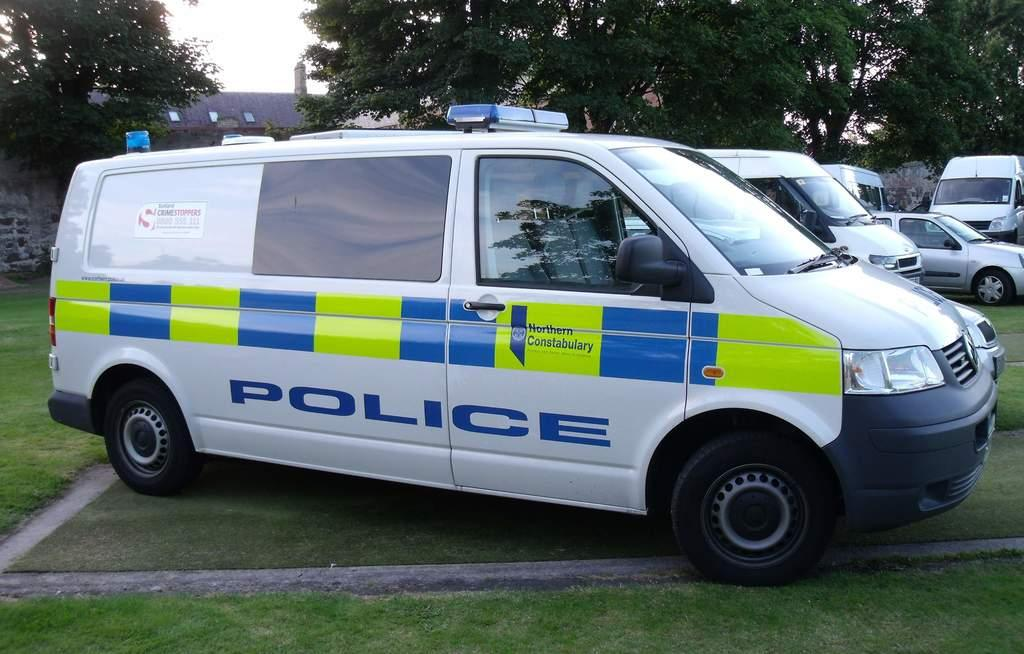Provide a one-sentence caption for the provided image. white police van parked on a patch of grass. 